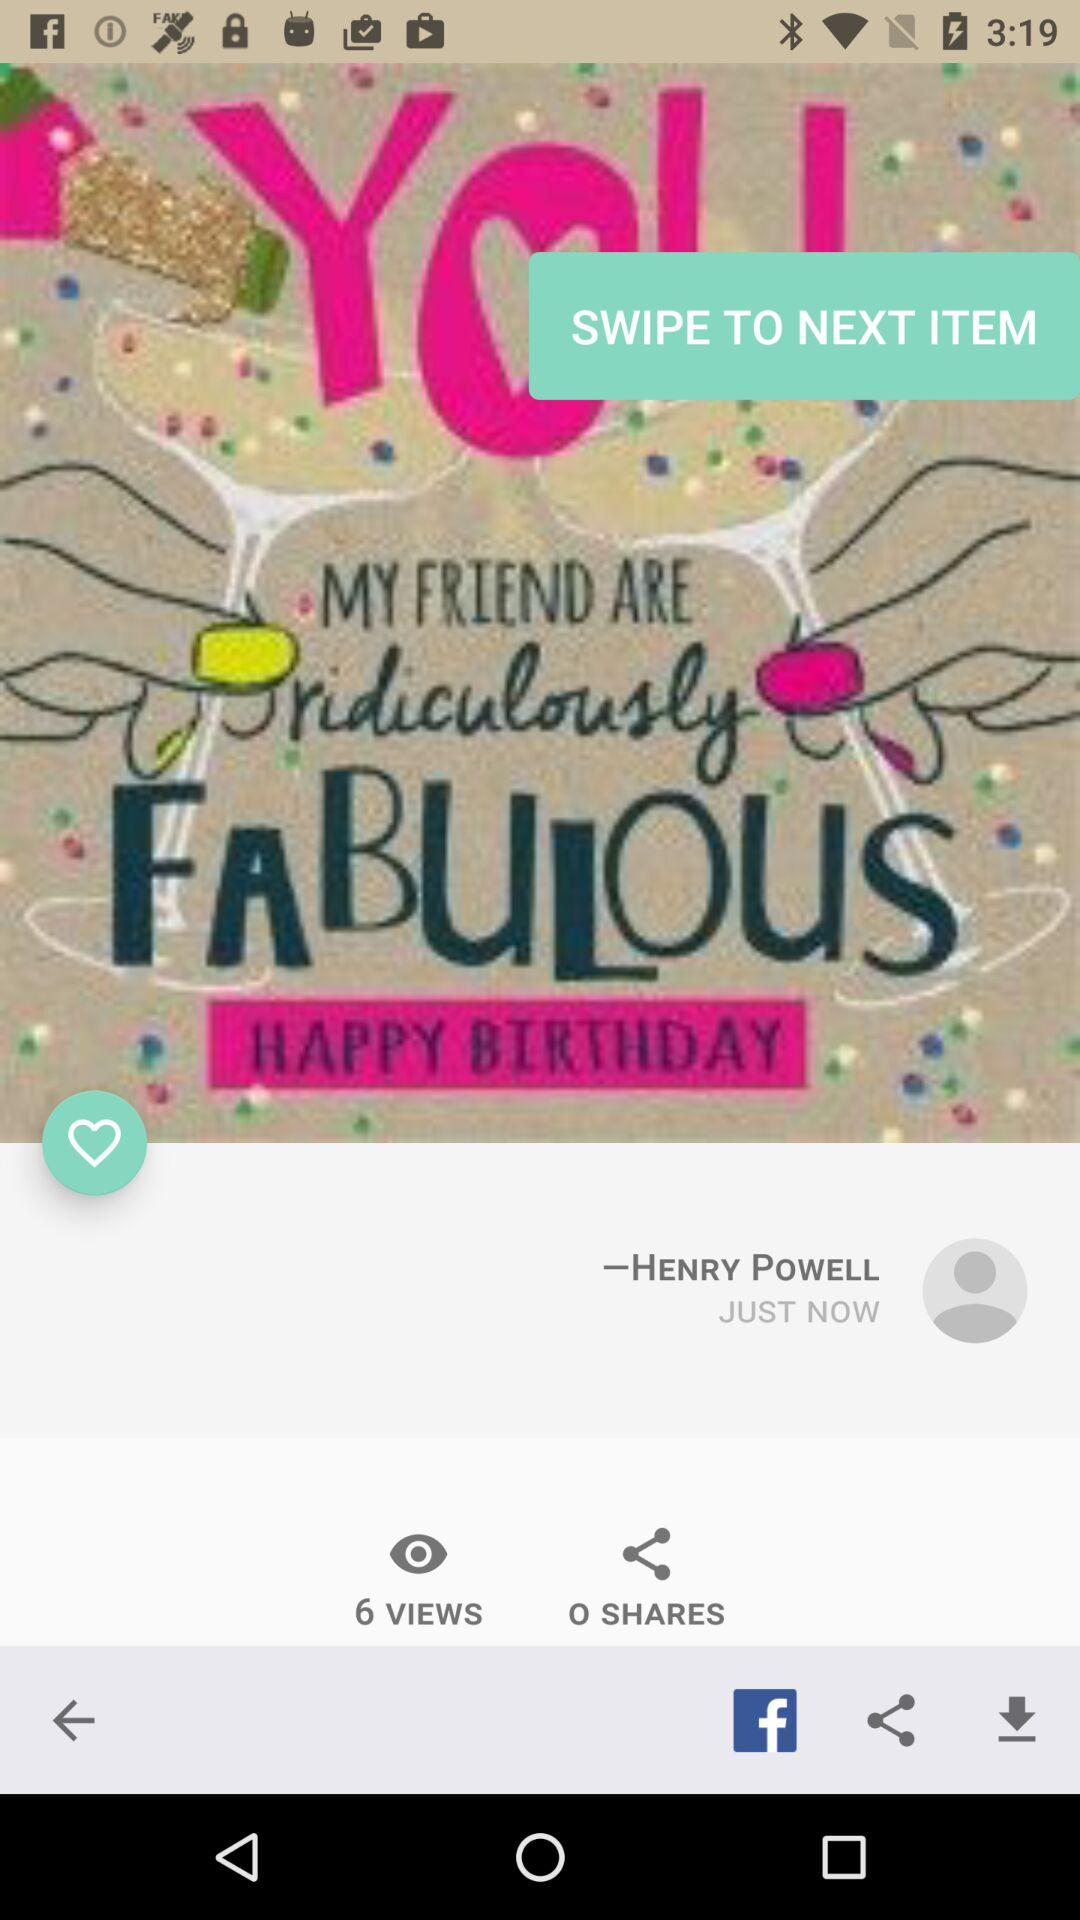How many shares are there of the photo? There are 0 shares of the photo. 